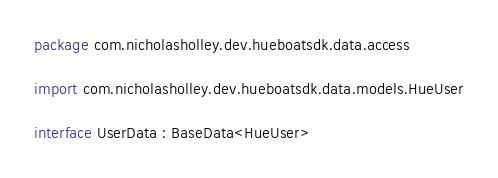Convert code to text. <code><loc_0><loc_0><loc_500><loc_500><_Kotlin_>package com.nicholasholley.dev.hueboatsdk.data.access

import com.nicholasholley.dev.hueboatsdk.data.models.HueUser

interface UserData : BaseData<HueUser></code> 